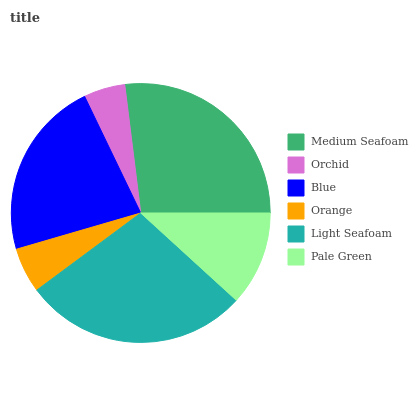Is Orchid the minimum?
Answer yes or no. Yes. Is Light Seafoam the maximum?
Answer yes or no. Yes. Is Blue the minimum?
Answer yes or no. No. Is Blue the maximum?
Answer yes or no. No. Is Blue greater than Orchid?
Answer yes or no. Yes. Is Orchid less than Blue?
Answer yes or no. Yes. Is Orchid greater than Blue?
Answer yes or no. No. Is Blue less than Orchid?
Answer yes or no. No. Is Blue the high median?
Answer yes or no. Yes. Is Pale Green the low median?
Answer yes or no. Yes. Is Medium Seafoam the high median?
Answer yes or no. No. Is Medium Seafoam the low median?
Answer yes or no. No. 